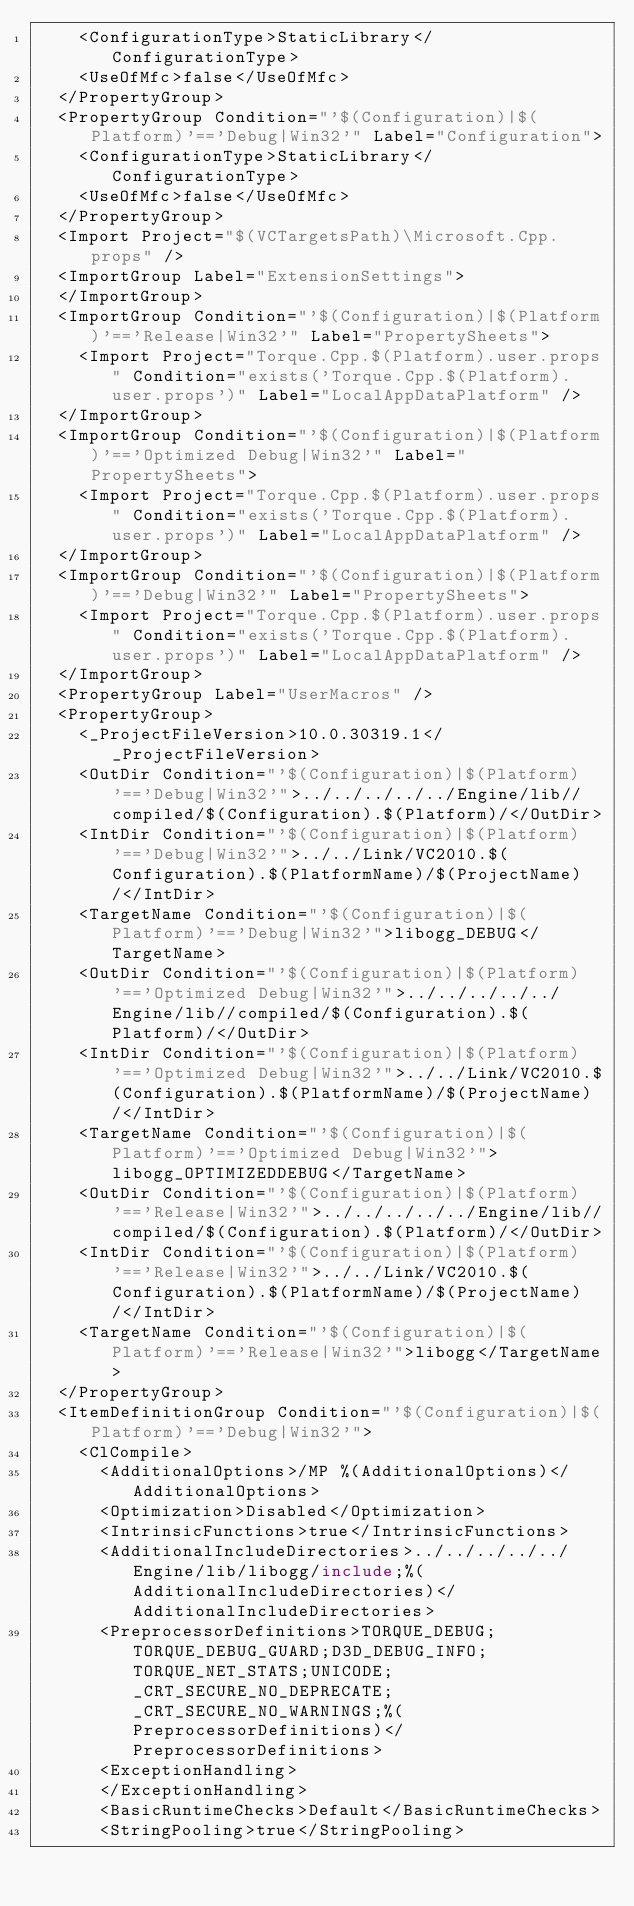Convert code to text. <code><loc_0><loc_0><loc_500><loc_500><_XML_>    <ConfigurationType>StaticLibrary</ConfigurationType>
    <UseOfMfc>false</UseOfMfc>
  </PropertyGroup>
  <PropertyGroup Condition="'$(Configuration)|$(Platform)'=='Debug|Win32'" Label="Configuration">
    <ConfigurationType>StaticLibrary</ConfigurationType>
    <UseOfMfc>false</UseOfMfc>
  </PropertyGroup>
  <Import Project="$(VCTargetsPath)\Microsoft.Cpp.props" />
  <ImportGroup Label="ExtensionSettings">
  </ImportGroup>
  <ImportGroup Condition="'$(Configuration)|$(Platform)'=='Release|Win32'" Label="PropertySheets">
    <Import Project="Torque.Cpp.$(Platform).user.props" Condition="exists('Torque.Cpp.$(Platform).user.props')" Label="LocalAppDataPlatform" />
  </ImportGroup>
  <ImportGroup Condition="'$(Configuration)|$(Platform)'=='Optimized Debug|Win32'" Label="PropertySheets">
    <Import Project="Torque.Cpp.$(Platform).user.props" Condition="exists('Torque.Cpp.$(Platform).user.props')" Label="LocalAppDataPlatform" />
  </ImportGroup>
  <ImportGroup Condition="'$(Configuration)|$(Platform)'=='Debug|Win32'" Label="PropertySheets">
    <Import Project="Torque.Cpp.$(Platform).user.props" Condition="exists('Torque.Cpp.$(Platform).user.props')" Label="LocalAppDataPlatform" />
  </ImportGroup>
  <PropertyGroup Label="UserMacros" />
  <PropertyGroup>
    <_ProjectFileVersion>10.0.30319.1</_ProjectFileVersion>
    <OutDir Condition="'$(Configuration)|$(Platform)'=='Debug|Win32'">../../../../../Engine/lib//compiled/$(Configuration).$(Platform)/</OutDir>
    <IntDir Condition="'$(Configuration)|$(Platform)'=='Debug|Win32'">../../Link/VC2010.$(Configuration).$(PlatformName)/$(ProjectName)/</IntDir>
    <TargetName Condition="'$(Configuration)|$(Platform)'=='Debug|Win32'">libogg_DEBUG</TargetName>
    <OutDir Condition="'$(Configuration)|$(Platform)'=='Optimized Debug|Win32'">../../../../../Engine/lib//compiled/$(Configuration).$(Platform)/</OutDir>
    <IntDir Condition="'$(Configuration)|$(Platform)'=='Optimized Debug|Win32'">../../Link/VC2010.$(Configuration).$(PlatformName)/$(ProjectName)/</IntDir>
    <TargetName Condition="'$(Configuration)|$(Platform)'=='Optimized Debug|Win32'">libogg_OPTIMIZEDDEBUG</TargetName>
    <OutDir Condition="'$(Configuration)|$(Platform)'=='Release|Win32'">../../../../../Engine/lib//compiled/$(Configuration).$(Platform)/</OutDir>
    <IntDir Condition="'$(Configuration)|$(Platform)'=='Release|Win32'">../../Link/VC2010.$(Configuration).$(PlatformName)/$(ProjectName)/</IntDir>
    <TargetName Condition="'$(Configuration)|$(Platform)'=='Release|Win32'">libogg</TargetName>
  </PropertyGroup>
  <ItemDefinitionGroup Condition="'$(Configuration)|$(Platform)'=='Debug|Win32'">
    <ClCompile>
      <AdditionalOptions>/MP %(AdditionalOptions)</AdditionalOptions>
      <Optimization>Disabled</Optimization>
      <IntrinsicFunctions>true</IntrinsicFunctions>
      <AdditionalIncludeDirectories>../../../../../Engine/lib/libogg/include;%(AdditionalIncludeDirectories)</AdditionalIncludeDirectories>
      <PreprocessorDefinitions>TORQUE_DEBUG;TORQUE_DEBUG_GUARD;D3D_DEBUG_INFO;TORQUE_NET_STATS;UNICODE;_CRT_SECURE_NO_DEPRECATE;_CRT_SECURE_NO_WARNINGS;%(PreprocessorDefinitions)</PreprocessorDefinitions>
      <ExceptionHandling>
      </ExceptionHandling>
      <BasicRuntimeChecks>Default</BasicRuntimeChecks>
      <StringPooling>true</StringPooling></code> 